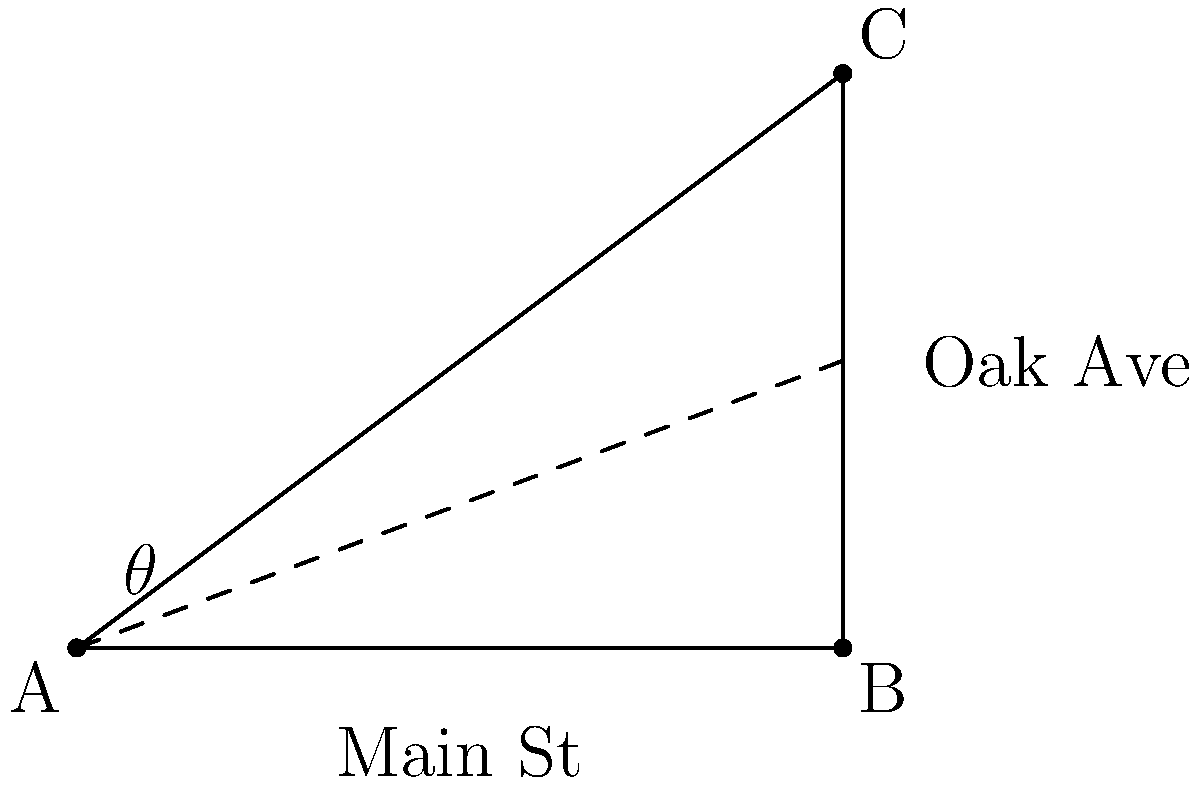You're considering opening a new store at the intersection of Main Street and Oak Avenue. On the city map, Main Street runs horizontally, and Oak Avenue intersects it at point B. If the distance from point A to B is 4 units, and the distance from B to C is 3 units, what is the angle $\theta$ between Main Street and Oak Avenue? How might this affect your decision on store placement for optimal visibility and accessibility? To solve this problem, we'll use the properties of right triangles and the arctangent function. Let's break it down step-by-step:

1. Identify the right triangle:
   The intersection forms a right triangle ABC, where:
   - AB is along Main Street
   - BC is the height of the triangle
   - AC is Oak Avenue

2. Given information:
   - AB = 4 units (base of the triangle)
   - BC = 3 units (height of the triangle)

3. Calculate the angle $\theta$:
   We can use the arctangent function, which gives us the angle when we know the opposite and adjacent sides of a right triangle.

   $\theta = \arctan(\frac{\text{opposite}}{\text{adjacent}}) = \arctan(\frac{BC}{AB})$

   $\theta = \arctan(\frac{3}{4})$

4. Evaluate:
   $\theta \approx 36.87°$

5. Business implications:
   - An angle of about 37° creates a relatively wide intersection, which could increase visibility for your store.
   - The wider angle might allow for easier access from both streets, potentially increasing foot and vehicle traffic.
   - However, it also means that the store front might not be perfectly aligned with either street, which could affect signage placement and storefront design.

6. Optimal placement:
   - Consider placing the store at point B for maximum visibility from both streets.
   - Alternatively, position slightly along Oak Avenue (between B and C) for better visibility to Main Street traffic while maintaining easy access from Oak Avenue.
Answer: $\theta = \arctan(\frac{3}{4}) \approx 36.87°$ 